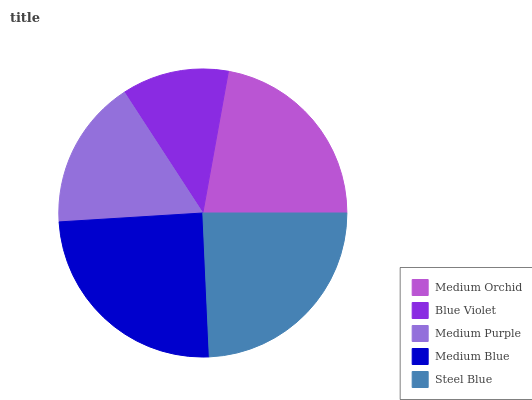Is Blue Violet the minimum?
Answer yes or no. Yes. Is Medium Blue the maximum?
Answer yes or no. Yes. Is Medium Purple the minimum?
Answer yes or no. No. Is Medium Purple the maximum?
Answer yes or no. No. Is Medium Purple greater than Blue Violet?
Answer yes or no. Yes. Is Blue Violet less than Medium Purple?
Answer yes or no. Yes. Is Blue Violet greater than Medium Purple?
Answer yes or no. No. Is Medium Purple less than Blue Violet?
Answer yes or no. No. Is Medium Orchid the high median?
Answer yes or no. Yes. Is Medium Orchid the low median?
Answer yes or no. Yes. Is Steel Blue the high median?
Answer yes or no. No. Is Medium Blue the low median?
Answer yes or no. No. 